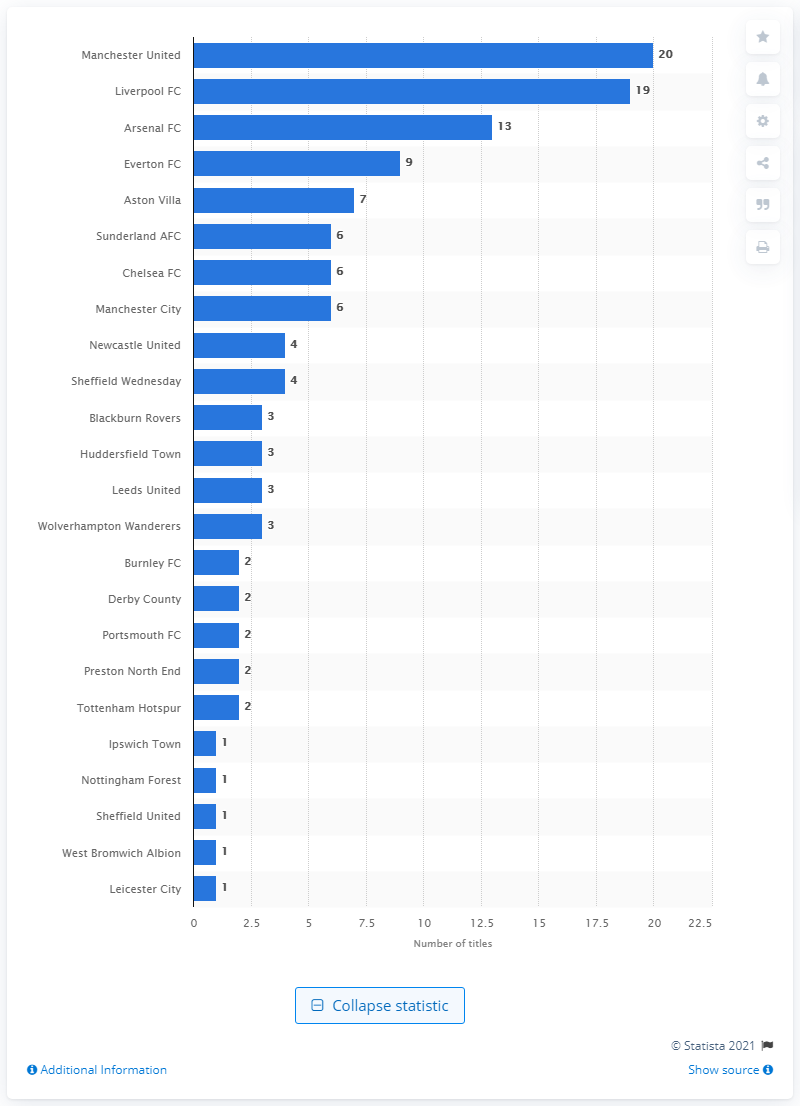Draw attention to some important aspects in this diagram. Liverpool Football Club has been crowned the most successful winner of the Football League Cup trophy with its impressive total of 18 titles. Arsenal Football Club has won a total of 13 FA Cup titles, making it one of the most successful teams in the history of the competition. 